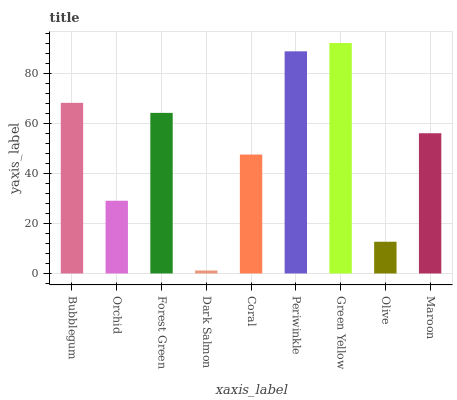Is Dark Salmon the minimum?
Answer yes or no. Yes. Is Green Yellow the maximum?
Answer yes or no. Yes. Is Orchid the minimum?
Answer yes or no. No. Is Orchid the maximum?
Answer yes or no. No. Is Bubblegum greater than Orchid?
Answer yes or no. Yes. Is Orchid less than Bubblegum?
Answer yes or no. Yes. Is Orchid greater than Bubblegum?
Answer yes or no. No. Is Bubblegum less than Orchid?
Answer yes or no. No. Is Maroon the high median?
Answer yes or no. Yes. Is Maroon the low median?
Answer yes or no. Yes. Is Periwinkle the high median?
Answer yes or no. No. Is Olive the low median?
Answer yes or no. No. 